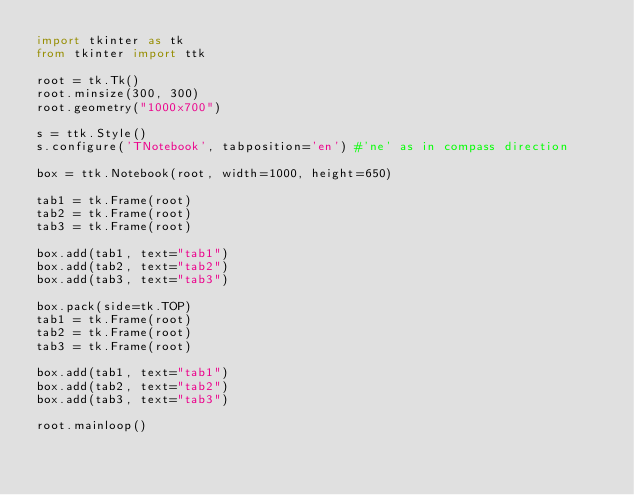Convert code to text. <code><loc_0><loc_0><loc_500><loc_500><_Python_>import tkinter as tk
from tkinter import ttk

root = tk.Tk()
root.minsize(300, 300)
root.geometry("1000x700")

s = ttk.Style()
s.configure('TNotebook', tabposition='en') #'ne' as in compass direction

box = ttk.Notebook(root, width=1000, height=650)

tab1 = tk.Frame(root)
tab2 = tk.Frame(root)
tab3 = tk.Frame(root)

box.add(tab1, text="tab1")
box.add(tab2, text="tab2")
box.add(tab3, text="tab3")

box.pack(side=tk.TOP)
tab1 = tk.Frame(root)
tab2 = tk.Frame(root)
tab3 = tk.Frame(root)

box.add(tab1, text="tab1")
box.add(tab2, text="tab2")
box.add(tab3, text="tab3")

root.mainloop()
</code> 